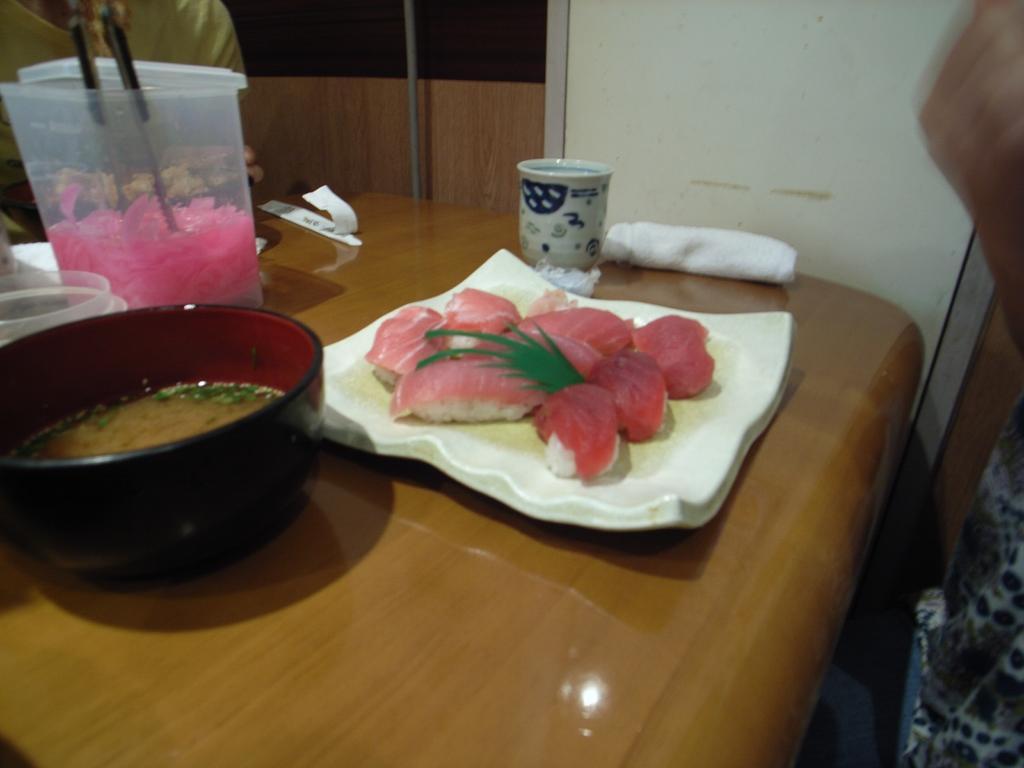Describe this image in one or two sentences. In this image there are food items on the plate , in a plastic container with two spoons in it and in a bowl , and there is a cup, cloth and other plastic container on the table , and there are two persons. 